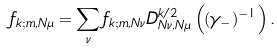Convert formula to latex. <formula><loc_0><loc_0><loc_500><loc_500>f _ { k ; m , N \mu } = \sum _ { \nu } f _ { k ; m , N \nu } D ^ { k / 2 } _ { N \nu , N \mu } \left ( ( \gamma _ { - } ) ^ { - 1 } \right ) .</formula> 